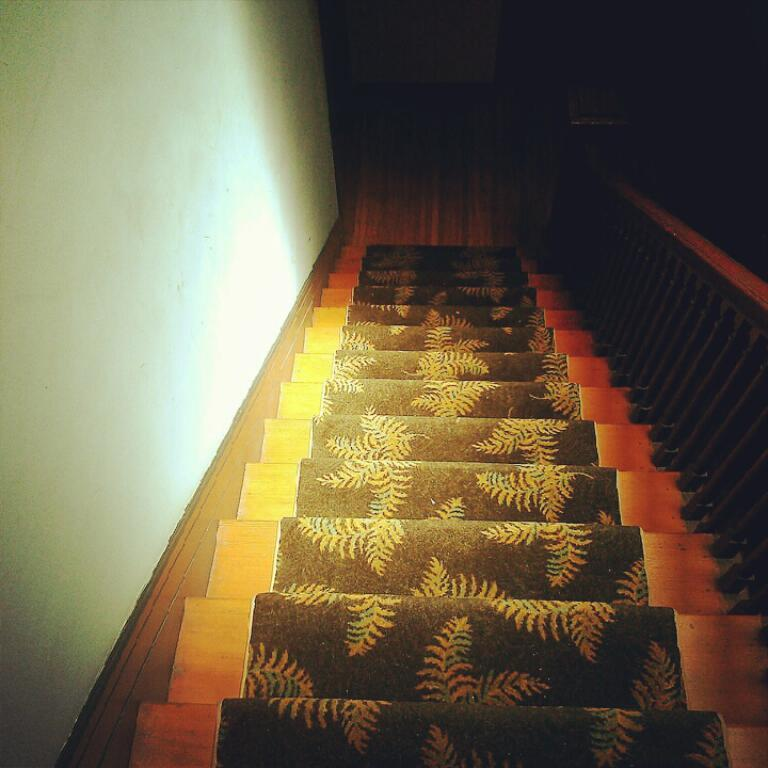What type of structure is visible in the image? There is a staircase in the image. What feature is present alongside the staircase? There is a railing in the image. What can be seen on the left side of the image? There is a wall on the left side of the image. What type of plantation can be seen in the image? There is no plantation present in the image; it features a staircase, railing, and a wall. What government building is depicted in the image? There is no government building depicted in the image. 